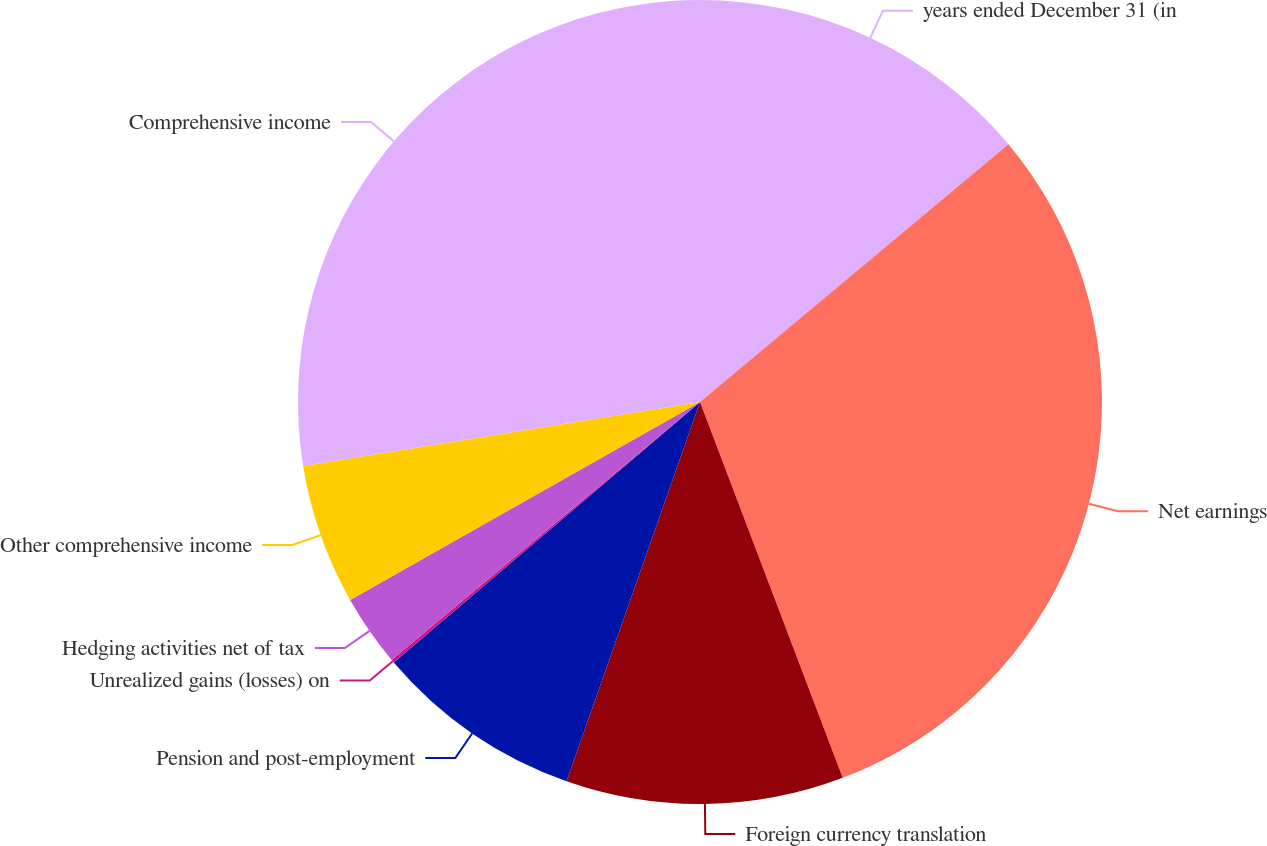Convert chart. <chart><loc_0><loc_0><loc_500><loc_500><pie_chart><fcel>years ended December 31 (in<fcel>Net earnings<fcel>Foreign currency translation<fcel>Pension and post-employment<fcel>Unrealized gains (losses) on<fcel>Hedging activities net of tax<fcel>Other comprehensive income<fcel>Comprehensive income<nl><fcel>13.92%<fcel>30.31%<fcel>11.16%<fcel>8.4%<fcel>0.13%<fcel>2.89%<fcel>5.65%<fcel>27.55%<nl></chart> 